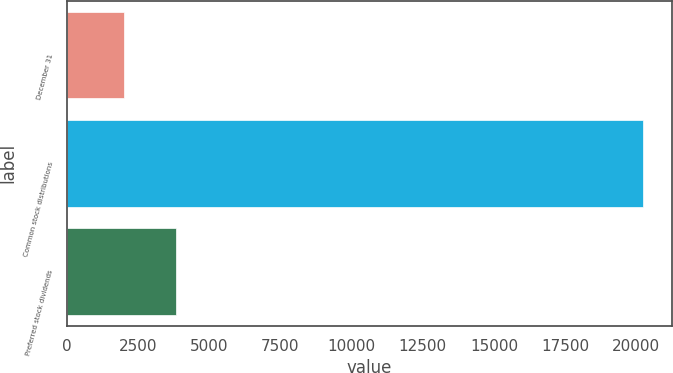Convert chart. <chart><loc_0><loc_0><loc_500><loc_500><bar_chart><fcel>December 31<fcel>Common stock distributions<fcel>Preferred stock dividends<nl><fcel>2012<fcel>20251<fcel>3835.9<nl></chart> 